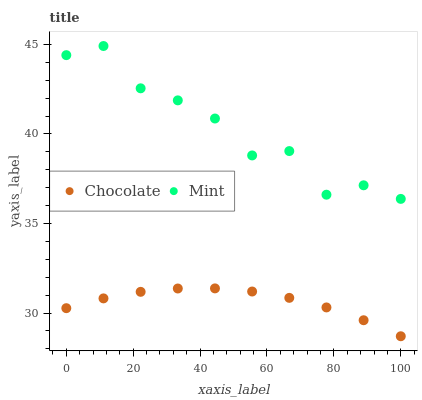Does Chocolate have the minimum area under the curve?
Answer yes or no. Yes. Does Mint have the maximum area under the curve?
Answer yes or no. Yes. Does Chocolate have the maximum area under the curve?
Answer yes or no. No. Is Chocolate the smoothest?
Answer yes or no. Yes. Is Mint the roughest?
Answer yes or no. Yes. Is Chocolate the roughest?
Answer yes or no. No. Does Chocolate have the lowest value?
Answer yes or no. Yes. Does Mint have the highest value?
Answer yes or no. Yes. Does Chocolate have the highest value?
Answer yes or no. No. Is Chocolate less than Mint?
Answer yes or no. Yes. Is Mint greater than Chocolate?
Answer yes or no. Yes. Does Chocolate intersect Mint?
Answer yes or no. No. 